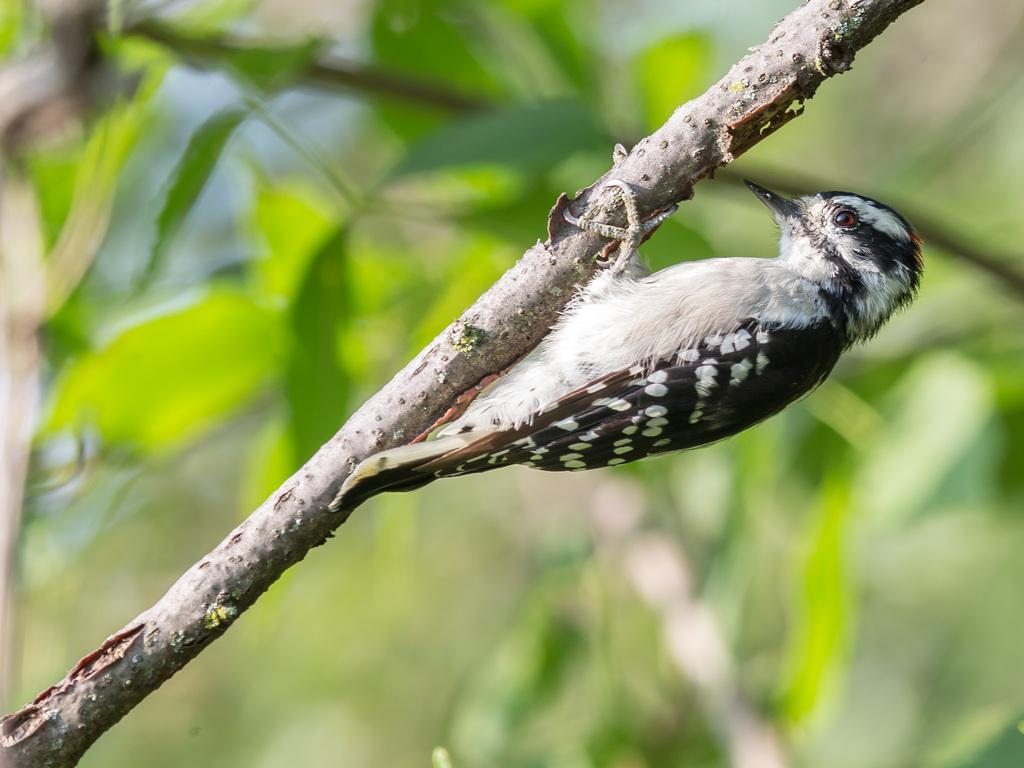What type of animal is in the image? There is a bird in the image. Can you describe the bird's coloring? The bird is white and black in color. Where is the bird located in the image? The bird is on a stem. What can be observed about the background of the image? The background is blurred. What type of print is visible on the notebook in the image? There is no notebook present in the image; it only features a bird on a stem with a blurred background. 